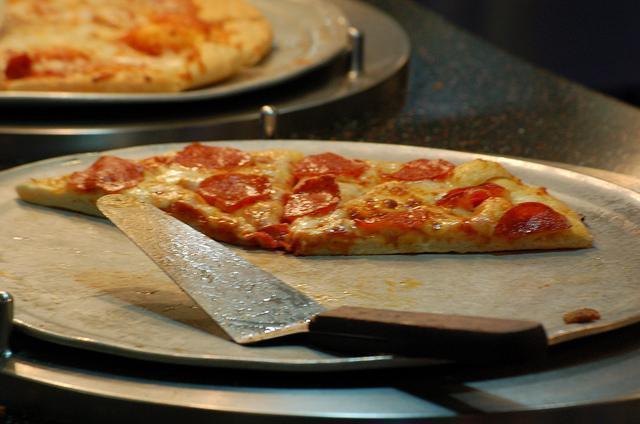How many pizzas are in the picture?
Give a very brief answer. 2. 